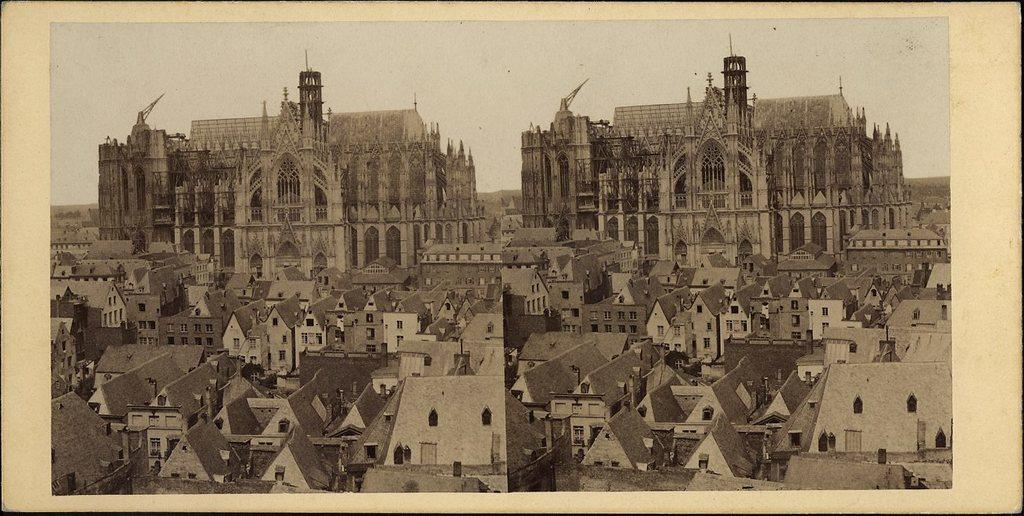What is a common feature between the two images? Both images contain buildings with windows. What can be seen in the background of both images? Sky is visible in the background of both images. Where is the cup placed in the image? There is no cup present in the image. What type of rake is being used to clean the windows in the image? There is no rake or window cleaning activity depicted in the image. 